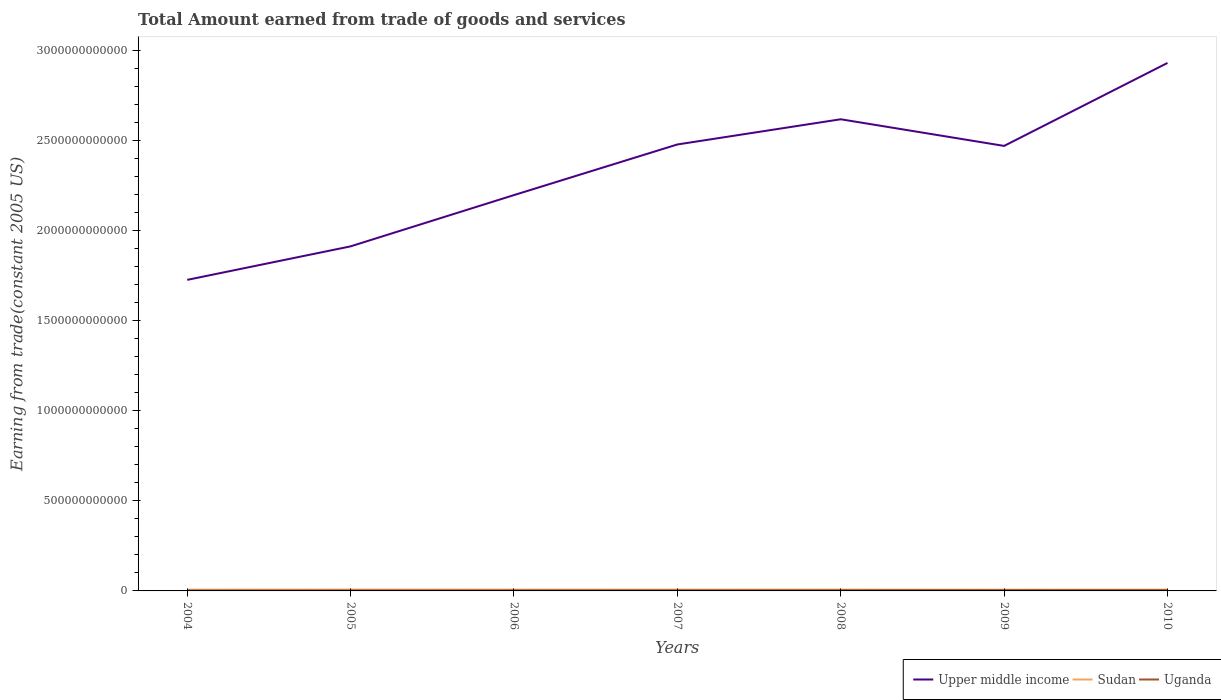How many different coloured lines are there?
Offer a very short reply. 3. Across all years, what is the maximum total amount earned by trading goods and services in Upper middle income?
Keep it short and to the point. 1.73e+12. In which year was the total amount earned by trading goods and services in Sudan maximum?
Your response must be concise. 2009. What is the total total amount earned by trading goods and services in Uganda in the graph?
Keep it short and to the point. 8.83e+07. What is the difference between the highest and the second highest total amount earned by trading goods and services in Uganda?
Provide a short and direct response. 2.28e+09. What is the difference between two consecutive major ticks on the Y-axis?
Your answer should be very brief. 5.00e+11. Are the values on the major ticks of Y-axis written in scientific E-notation?
Your answer should be compact. No. Does the graph contain any zero values?
Keep it short and to the point. No. Where does the legend appear in the graph?
Provide a short and direct response. Bottom right. How many legend labels are there?
Ensure brevity in your answer.  3. How are the legend labels stacked?
Your answer should be very brief. Horizontal. What is the title of the graph?
Your answer should be very brief. Total Amount earned from trade of goods and services. What is the label or title of the X-axis?
Offer a very short reply. Years. What is the label or title of the Y-axis?
Your answer should be compact. Earning from trade(constant 2005 US). What is the Earning from trade(constant 2005 US) of Upper middle income in 2004?
Give a very brief answer. 1.73e+12. What is the Earning from trade(constant 2005 US) in Sudan in 2004?
Give a very brief answer. 6.97e+09. What is the Earning from trade(constant 2005 US) of Uganda in 2004?
Your answer should be compact. 1.99e+09. What is the Earning from trade(constant 2005 US) of Upper middle income in 2005?
Your answer should be very brief. 1.91e+12. What is the Earning from trade(constant 2005 US) in Sudan in 2005?
Offer a terse response. 7.53e+09. What is the Earning from trade(constant 2005 US) in Uganda in 2005?
Your response must be concise. 2.24e+09. What is the Earning from trade(constant 2005 US) of Upper middle income in 2006?
Provide a short and direct response. 2.20e+12. What is the Earning from trade(constant 2005 US) of Sudan in 2006?
Make the answer very short. 7.20e+09. What is the Earning from trade(constant 2005 US) of Uganda in 2006?
Your answer should be very brief. 2.67e+09. What is the Earning from trade(constant 2005 US) of Upper middle income in 2007?
Ensure brevity in your answer.  2.48e+12. What is the Earning from trade(constant 2005 US) in Sudan in 2007?
Provide a succinct answer. 7.22e+09. What is the Earning from trade(constant 2005 US) of Uganda in 2007?
Your answer should be compact. 3.11e+09. What is the Earning from trade(constant 2005 US) in Upper middle income in 2008?
Make the answer very short. 2.62e+12. What is the Earning from trade(constant 2005 US) of Sudan in 2008?
Offer a very short reply. 7.24e+09. What is the Earning from trade(constant 2005 US) in Uganda in 2008?
Your answer should be compact. 3.65e+09. What is the Earning from trade(constant 2005 US) in Upper middle income in 2009?
Your answer should be very brief. 2.47e+12. What is the Earning from trade(constant 2005 US) of Sudan in 2009?
Your answer should be very brief. 6.72e+09. What is the Earning from trade(constant 2005 US) in Uganda in 2009?
Make the answer very short. 4.27e+09. What is the Earning from trade(constant 2005 US) in Upper middle income in 2010?
Your answer should be compact. 2.93e+12. What is the Earning from trade(constant 2005 US) of Sudan in 2010?
Keep it short and to the point. 7.17e+09. What is the Earning from trade(constant 2005 US) in Uganda in 2010?
Offer a terse response. 4.18e+09. Across all years, what is the maximum Earning from trade(constant 2005 US) of Upper middle income?
Ensure brevity in your answer.  2.93e+12. Across all years, what is the maximum Earning from trade(constant 2005 US) of Sudan?
Provide a succinct answer. 7.53e+09. Across all years, what is the maximum Earning from trade(constant 2005 US) of Uganda?
Your answer should be very brief. 4.27e+09. Across all years, what is the minimum Earning from trade(constant 2005 US) of Upper middle income?
Ensure brevity in your answer.  1.73e+12. Across all years, what is the minimum Earning from trade(constant 2005 US) of Sudan?
Offer a very short reply. 6.72e+09. Across all years, what is the minimum Earning from trade(constant 2005 US) of Uganda?
Offer a terse response. 1.99e+09. What is the total Earning from trade(constant 2005 US) of Upper middle income in the graph?
Your response must be concise. 1.63e+13. What is the total Earning from trade(constant 2005 US) of Sudan in the graph?
Keep it short and to the point. 5.01e+1. What is the total Earning from trade(constant 2005 US) of Uganda in the graph?
Keep it short and to the point. 2.21e+1. What is the difference between the Earning from trade(constant 2005 US) in Upper middle income in 2004 and that in 2005?
Give a very brief answer. -1.86e+11. What is the difference between the Earning from trade(constant 2005 US) in Sudan in 2004 and that in 2005?
Ensure brevity in your answer.  -5.68e+08. What is the difference between the Earning from trade(constant 2005 US) in Uganda in 2004 and that in 2005?
Keep it short and to the point. -2.50e+08. What is the difference between the Earning from trade(constant 2005 US) of Upper middle income in 2004 and that in 2006?
Offer a terse response. -4.70e+11. What is the difference between the Earning from trade(constant 2005 US) of Sudan in 2004 and that in 2006?
Your response must be concise. -2.36e+08. What is the difference between the Earning from trade(constant 2005 US) of Uganda in 2004 and that in 2006?
Keep it short and to the point. -6.86e+08. What is the difference between the Earning from trade(constant 2005 US) in Upper middle income in 2004 and that in 2007?
Your answer should be very brief. -7.51e+11. What is the difference between the Earning from trade(constant 2005 US) in Sudan in 2004 and that in 2007?
Your answer should be very brief. -2.58e+08. What is the difference between the Earning from trade(constant 2005 US) of Uganda in 2004 and that in 2007?
Ensure brevity in your answer.  -1.12e+09. What is the difference between the Earning from trade(constant 2005 US) of Upper middle income in 2004 and that in 2008?
Ensure brevity in your answer.  -8.91e+11. What is the difference between the Earning from trade(constant 2005 US) of Sudan in 2004 and that in 2008?
Your answer should be compact. -2.79e+08. What is the difference between the Earning from trade(constant 2005 US) of Uganda in 2004 and that in 2008?
Offer a very short reply. -1.66e+09. What is the difference between the Earning from trade(constant 2005 US) in Upper middle income in 2004 and that in 2009?
Your answer should be very brief. -7.43e+11. What is the difference between the Earning from trade(constant 2005 US) of Sudan in 2004 and that in 2009?
Your response must be concise. 2.51e+08. What is the difference between the Earning from trade(constant 2005 US) in Uganda in 2004 and that in 2009?
Provide a short and direct response. -2.28e+09. What is the difference between the Earning from trade(constant 2005 US) in Upper middle income in 2004 and that in 2010?
Provide a short and direct response. -1.20e+12. What is the difference between the Earning from trade(constant 2005 US) in Sudan in 2004 and that in 2010?
Your answer should be compact. -2.04e+08. What is the difference between the Earning from trade(constant 2005 US) in Uganda in 2004 and that in 2010?
Ensure brevity in your answer.  -2.19e+09. What is the difference between the Earning from trade(constant 2005 US) of Upper middle income in 2005 and that in 2006?
Provide a short and direct response. -2.84e+11. What is the difference between the Earning from trade(constant 2005 US) of Sudan in 2005 and that in 2006?
Offer a terse response. 3.31e+08. What is the difference between the Earning from trade(constant 2005 US) in Uganda in 2005 and that in 2006?
Keep it short and to the point. -4.37e+08. What is the difference between the Earning from trade(constant 2005 US) in Upper middle income in 2005 and that in 2007?
Your answer should be very brief. -5.65e+11. What is the difference between the Earning from trade(constant 2005 US) of Sudan in 2005 and that in 2007?
Your answer should be compact. 3.10e+08. What is the difference between the Earning from trade(constant 2005 US) in Uganda in 2005 and that in 2007?
Make the answer very short. -8.74e+08. What is the difference between the Earning from trade(constant 2005 US) of Upper middle income in 2005 and that in 2008?
Make the answer very short. -7.05e+11. What is the difference between the Earning from trade(constant 2005 US) of Sudan in 2005 and that in 2008?
Ensure brevity in your answer.  2.89e+08. What is the difference between the Earning from trade(constant 2005 US) of Uganda in 2005 and that in 2008?
Keep it short and to the point. -1.41e+09. What is the difference between the Earning from trade(constant 2005 US) in Upper middle income in 2005 and that in 2009?
Your answer should be very brief. -5.57e+11. What is the difference between the Earning from trade(constant 2005 US) in Sudan in 2005 and that in 2009?
Keep it short and to the point. 8.18e+08. What is the difference between the Earning from trade(constant 2005 US) in Uganda in 2005 and that in 2009?
Offer a terse response. -2.03e+09. What is the difference between the Earning from trade(constant 2005 US) in Upper middle income in 2005 and that in 2010?
Keep it short and to the point. -1.02e+12. What is the difference between the Earning from trade(constant 2005 US) in Sudan in 2005 and that in 2010?
Provide a short and direct response. 3.64e+08. What is the difference between the Earning from trade(constant 2005 US) in Uganda in 2005 and that in 2010?
Offer a very short reply. -1.94e+09. What is the difference between the Earning from trade(constant 2005 US) in Upper middle income in 2006 and that in 2007?
Your response must be concise. -2.81e+11. What is the difference between the Earning from trade(constant 2005 US) of Sudan in 2006 and that in 2007?
Ensure brevity in your answer.  -2.13e+07. What is the difference between the Earning from trade(constant 2005 US) in Uganda in 2006 and that in 2007?
Your answer should be compact. -4.37e+08. What is the difference between the Earning from trade(constant 2005 US) of Upper middle income in 2006 and that in 2008?
Provide a succinct answer. -4.21e+11. What is the difference between the Earning from trade(constant 2005 US) of Sudan in 2006 and that in 2008?
Your answer should be compact. -4.25e+07. What is the difference between the Earning from trade(constant 2005 US) in Uganda in 2006 and that in 2008?
Your answer should be compact. -9.78e+08. What is the difference between the Earning from trade(constant 2005 US) of Upper middle income in 2006 and that in 2009?
Make the answer very short. -2.73e+11. What is the difference between the Earning from trade(constant 2005 US) of Sudan in 2006 and that in 2009?
Ensure brevity in your answer.  4.87e+08. What is the difference between the Earning from trade(constant 2005 US) in Uganda in 2006 and that in 2009?
Offer a terse response. -1.59e+09. What is the difference between the Earning from trade(constant 2005 US) of Upper middle income in 2006 and that in 2010?
Your answer should be very brief. -7.33e+11. What is the difference between the Earning from trade(constant 2005 US) in Sudan in 2006 and that in 2010?
Your response must be concise. 3.29e+07. What is the difference between the Earning from trade(constant 2005 US) in Uganda in 2006 and that in 2010?
Ensure brevity in your answer.  -1.50e+09. What is the difference between the Earning from trade(constant 2005 US) in Upper middle income in 2007 and that in 2008?
Ensure brevity in your answer.  -1.40e+11. What is the difference between the Earning from trade(constant 2005 US) of Sudan in 2007 and that in 2008?
Your response must be concise. -2.12e+07. What is the difference between the Earning from trade(constant 2005 US) of Uganda in 2007 and that in 2008?
Your answer should be very brief. -5.40e+08. What is the difference between the Earning from trade(constant 2005 US) in Upper middle income in 2007 and that in 2009?
Give a very brief answer. 8.00e+09. What is the difference between the Earning from trade(constant 2005 US) of Sudan in 2007 and that in 2009?
Your response must be concise. 5.08e+08. What is the difference between the Earning from trade(constant 2005 US) in Uganda in 2007 and that in 2009?
Offer a very short reply. -1.16e+09. What is the difference between the Earning from trade(constant 2005 US) of Upper middle income in 2007 and that in 2010?
Keep it short and to the point. -4.52e+11. What is the difference between the Earning from trade(constant 2005 US) of Sudan in 2007 and that in 2010?
Your response must be concise. 5.42e+07. What is the difference between the Earning from trade(constant 2005 US) of Uganda in 2007 and that in 2010?
Keep it short and to the point. -1.07e+09. What is the difference between the Earning from trade(constant 2005 US) in Upper middle income in 2008 and that in 2009?
Offer a very short reply. 1.48e+11. What is the difference between the Earning from trade(constant 2005 US) in Sudan in 2008 and that in 2009?
Ensure brevity in your answer.  5.30e+08. What is the difference between the Earning from trade(constant 2005 US) of Uganda in 2008 and that in 2009?
Give a very brief answer. -6.15e+08. What is the difference between the Earning from trade(constant 2005 US) of Upper middle income in 2008 and that in 2010?
Give a very brief answer. -3.12e+11. What is the difference between the Earning from trade(constant 2005 US) of Sudan in 2008 and that in 2010?
Ensure brevity in your answer.  7.54e+07. What is the difference between the Earning from trade(constant 2005 US) of Uganda in 2008 and that in 2010?
Ensure brevity in your answer.  -5.27e+08. What is the difference between the Earning from trade(constant 2005 US) of Upper middle income in 2009 and that in 2010?
Ensure brevity in your answer.  -4.60e+11. What is the difference between the Earning from trade(constant 2005 US) in Sudan in 2009 and that in 2010?
Offer a very short reply. -4.54e+08. What is the difference between the Earning from trade(constant 2005 US) of Uganda in 2009 and that in 2010?
Ensure brevity in your answer.  8.83e+07. What is the difference between the Earning from trade(constant 2005 US) of Upper middle income in 2004 and the Earning from trade(constant 2005 US) of Sudan in 2005?
Your answer should be very brief. 1.72e+12. What is the difference between the Earning from trade(constant 2005 US) in Upper middle income in 2004 and the Earning from trade(constant 2005 US) in Uganda in 2005?
Provide a succinct answer. 1.72e+12. What is the difference between the Earning from trade(constant 2005 US) of Sudan in 2004 and the Earning from trade(constant 2005 US) of Uganda in 2005?
Your answer should be compact. 4.73e+09. What is the difference between the Earning from trade(constant 2005 US) in Upper middle income in 2004 and the Earning from trade(constant 2005 US) in Sudan in 2006?
Provide a short and direct response. 1.72e+12. What is the difference between the Earning from trade(constant 2005 US) in Upper middle income in 2004 and the Earning from trade(constant 2005 US) in Uganda in 2006?
Provide a short and direct response. 1.72e+12. What is the difference between the Earning from trade(constant 2005 US) in Sudan in 2004 and the Earning from trade(constant 2005 US) in Uganda in 2006?
Your response must be concise. 4.29e+09. What is the difference between the Earning from trade(constant 2005 US) of Upper middle income in 2004 and the Earning from trade(constant 2005 US) of Sudan in 2007?
Offer a very short reply. 1.72e+12. What is the difference between the Earning from trade(constant 2005 US) of Upper middle income in 2004 and the Earning from trade(constant 2005 US) of Uganda in 2007?
Your response must be concise. 1.72e+12. What is the difference between the Earning from trade(constant 2005 US) in Sudan in 2004 and the Earning from trade(constant 2005 US) in Uganda in 2007?
Provide a succinct answer. 3.86e+09. What is the difference between the Earning from trade(constant 2005 US) in Upper middle income in 2004 and the Earning from trade(constant 2005 US) in Sudan in 2008?
Offer a very short reply. 1.72e+12. What is the difference between the Earning from trade(constant 2005 US) in Upper middle income in 2004 and the Earning from trade(constant 2005 US) in Uganda in 2008?
Keep it short and to the point. 1.72e+12. What is the difference between the Earning from trade(constant 2005 US) in Sudan in 2004 and the Earning from trade(constant 2005 US) in Uganda in 2008?
Ensure brevity in your answer.  3.31e+09. What is the difference between the Earning from trade(constant 2005 US) of Upper middle income in 2004 and the Earning from trade(constant 2005 US) of Sudan in 2009?
Your answer should be very brief. 1.72e+12. What is the difference between the Earning from trade(constant 2005 US) of Upper middle income in 2004 and the Earning from trade(constant 2005 US) of Uganda in 2009?
Your answer should be very brief. 1.72e+12. What is the difference between the Earning from trade(constant 2005 US) in Sudan in 2004 and the Earning from trade(constant 2005 US) in Uganda in 2009?
Keep it short and to the point. 2.70e+09. What is the difference between the Earning from trade(constant 2005 US) of Upper middle income in 2004 and the Earning from trade(constant 2005 US) of Sudan in 2010?
Give a very brief answer. 1.72e+12. What is the difference between the Earning from trade(constant 2005 US) of Upper middle income in 2004 and the Earning from trade(constant 2005 US) of Uganda in 2010?
Your answer should be compact. 1.72e+12. What is the difference between the Earning from trade(constant 2005 US) in Sudan in 2004 and the Earning from trade(constant 2005 US) in Uganda in 2010?
Your answer should be compact. 2.79e+09. What is the difference between the Earning from trade(constant 2005 US) of Upper middle income in 2005 and the Earning from trade(constant 2005 US) of Sudan in 2006?
Your answer should be compact. 1.90e+12. What is the difference between the Earning from trade(constant 2005 US) of Upper middle income in 2005 and the Earning from trade(constant 2005 US) of Uganda in 2006?
Your response must be concise. 1.91e+12. What is the difference between the Earning from trade(constant 2005 US) of Sudan in 2005 and the Earning from trade(constant 2005 US) of Uganda in 2006?
Offer a terse response. 4.86e+09. What is the difference between the Earning from trade(constant 2005 US) in Upper middle income in 2005 and the Earning from trade(constant 2005 US) in Sudan in 2007?
Keep it short and to the point. 1.90e+12. What is the difference between the Earning from trade(constant 2005 US) of Upper middle income in 2005 and the Earning from trade(constant 2005 US) of Uganda in 2007?
Offer a very short reply. 1.91e+12. What is the difference between the Earning from trade(constant 2005 US) in Sudan in 2005 and the Earning from trade(constant 2005 US) in Uganda in 2007?
Offer a terse response. 4.42e+09. What is the difference between the Earning from trade(constant 2005 US) in Upper middle income in 2005 and the Earning from trade(constant 2005 US) in Sudan in 2008?
Your answer should be compact. 1.90e+12. What is the difference between the Earning from trade(constant 2005 US) of Upper middle income in 2005 and the Earning from trade(constant 2005 US) of Uganda in 2008?
Provide a succinct answer. 1.91e+12. What is the difference between the Earning from trade(constant 2005 US) in Sudan in 2005 and the Earning from trade(constant 2005 US) in Uganda in 2008?
Offer a terse response. 3.88e+09. What is the difference between the Earning from trade(constant 2005 US) of Upper middle income in 2005 and the Earning from trade(constant 2005 US) of Sudan in 2009?
Ensure brevity in your answer.  1.90e+12. What is the difference between the Earning from trade(constant 2005 US) of Upper middle income in 2005 and the Earning from trade(constant 2005 US) of Uganda in 2009?
Make the answer very short. 1.91e+12. What is the difference between the Earning from trade(constant 2005 US) of Sudan in 2005 and the Earning from trade(constant 2005 US) of Uganda in 2009?
Keep it short and to the point. 3.27e+09. What is the difference between the Earning from trade(constant 2005 US) of Upper middle income in 2005 and the Earning from trade(constant 2005 US) of Sudan in 2010?
Offer a very short reply. 1.90e+12. What is the difference between the Earning from trade(constant 2005 US) in Upper middle income in 2005 and the Earning from trade(constant 2005 US) in Uganda in 2010?
Make the answer very short. 1.91e+12. What is the difference between the Earning from trade(constant 2005 US) of Sudan in 2005 and the Earning from trade(constant 2005 US) of Uganda in 2010?
Provide a succinct answer. 3.36e+09. What is the difference between the Earning from trade(constant 2005 US) in Upper middle income in 2006 and the Earning from trade(constant 2005 US) in Sudan in 2007?
Your answer should be compact. 2.19e+12. What is the difference between the Earning from trade(constant 2005 US) in Upper middle income in 2006 and the Earning from trade(constant 2005 US) in Uganda in 2007?
Ensure brevity in your answer.  2.19e+12. What is the difference between the Earning from trade(constant 2005 US) of Sudan in 2006 and the Earning from trade(constant 2005 US) of Uganda in 2007?
Provide a succinct answer. 4.09e+09. What is the difference between the Earning from trade(constant 2005 US) of Upper middle income in 2006 and the Earning from trade(constant 2005 US) of Sudan in 2008?
Give a very brief answer. 2.19e+12. What is the difference between the Earning from trade(constant 2005 US) of Upper middle income in 2006 and the Earning from trade(constant 2005 US) of Uganda in 2008?
Make the answer very short. 2.19e+12. What is the difference between the Earning from trade(constant 2005 US) of Sudan in 2006 and the Earning from trade(constant 2005 US) of Uganda in 2008?
Keep it short and to the point. 3.55e+09. What is the difference between the Earning from trade(constant 2005 US) in Upper middle income in 2006 and the Earning from trade(constant 2005 US) in Sudan in 2009?
Provide a short and direct response. 2.19e+12. What is the difference between the Earning from trade(constant 2005 US) of Upper middle income in 2006 and the Earning from trade(constant 2005 US) of Uganda in 2009?
Give a very brief answer. 2.19e+12. What is the difference between the Earning from trade(constant 2005 US) of Sudan in 2006 and the Earning from trade(constant 2005 US) of Uganda in 2009?
Ensure brevity in your answer.  2.94e+09. What is the difference between the Earning from trade(constant 2005 US) in Upper middle income in 2006 and the Earning from trade(constant 2005 US) in Sudan in 2010?
Your answer should be very brief. 2.19e+12. What is the difference between the Earning from trade(constant 2005 US) of Upper middle income in 2006 and the Earning from trade(constant 2005 US) of Uganda in 2010?
Provide a short and direct response. 2.19e+12. What is the difference between the Earning from trade(constant 2005 US) of Sudan in 2006 and the Earning from trade(constant 2005 US) of Uganda in 2010?
Offer a terse response. 3.02e+09. What is the difference between the Earning from trade(constant 2005 US) of Upper middle income in 2007 and the Earning from trade(constant 2005 US) of Sudan in 2008?
Ensure brevity in your answer.  2.47e+12. What is the difference between the Earning from trade(constant 2005 US) in Upper middle income in 2007 and the Earning from trade(constant 2005 US) in Uganda in 2008?
Give a very brief answer. 2.47e+12. What is the difference between the Earning from trade(constant 2005 US) of Sudan in 2007 and the Earning from trade(constant 2005 US) of Uganda in 2008?
Give a very brief answer. 3.57e+09. What is the difference between the Earning from trade(constant 2005 US) of Upper middle income in 2007 and the Earning from trade(constant 2005 US) of Sudan in 2009?
Ensure brevity in your answer.  2.47e+12. What is the difference between the Earning from trade(constant 2005 US) in Upper middle income in 2007 and the Earning from trade(constant 2005 US) in Uganda in 2009?
Provide a succinct answer. 2.47e+12. What is the difference between the Earning from trade(constant 2005 US) in Sudan in 2007 and the Earning from trade(constant 2005 US) in Uganda in 2009?
Offer a very short reply. 2.96e+09. What is the difference between the Earning from trade(constant 2005 US) of Upper middle income in 2007 and the Earning from trade(constant 2005 US) of Sudan in 2010?
Keep it short and to the point. 2.47e+12. What is the difference between the Earning from trade(constant 2005 US) of Upper middle income in 2007 and the Earning from trade(constant 2005 US) of Uganda in 2010?
Your response must be concise. 2.47e+12. What is the difference between the Earning from trade(constant 2005 US) in Sudan in 2007 and the Earning from trade(constant 2005 US) in Uganda in 2010?
Keep it short and to the point. 3.05e+09. What is the difference between the Earning from trade(constant 2005 US) of Upper middle income in 2008 and the Earning from trade(constant 2005 US) of Sudan in 2009?
Ensure brevity in your answer.  2.61e+12. What is the difference between the Earning from trade(constant 2005 US) in Upper middle income in 2008 and the Earning from trade(constant 2005 US) in Uganda in 2009?
Make the answer very short. 2.61e+12. What is the difference between the Earning from trade(constant 2005 US) of Sudan in 2008 and the Earning from trade(constant 2005 US) of Uganda in 2009?
Your response must be concise. 2.98e+09. What is the difference between the Earning from trade(constant 2005 US) of Upper middle income in 2008 and the Earning from trade(constant 2005 US) of Sudan in 2010?
Your response must be concise. 2.61e+12. What is the difference between the Earning from trade(constant 2005 US) in Upper middle income in 2008 and the Earning from trade(constant 2005 US) in Uganda in 2010?
Your response must be concise. 2.61e+12. What is the difference between the Earning from trade(constant 2005 US) in Sudan in 2008 and the Earning from trade(constant 2005 US) in Uganda in 2010?
Ensure brevity in your answer.  3.07e+09. What is the difference between the Earning from trade(constant 2005 US) of Upper middle income in 2009 and the Earning from trade(constant 2005 US) of Sudan in 2010?
Give a very brief answer. 2.46e+12. What is the difference between the Earning from trade(constant 2005 US) in Upper middle income in 2009 and the Earning from trade(constant 2005 US) in Uganda in 2010?
Provide a succinct answer. 2.46e+12. What is the difference between the Earning from trade(constant 2005 US) of Sudan in 2009 and the Earning from trade(constant 2005 US) of Uganda in 2010?
Keep it short and to the point. 2.54e+09. What is the average Earning from trade(constant 2005 US) in Upper middle income per year?
Your answer should be very brief. 2.33e+12. What is the average Earning from trade(constant 2005 US) of Sudan per year?
Make the answer very short. 7.15e+09. What is the average Earning from trade(constant 2005 US) in Uganda per year?
Offer a terse response. 3.16e+09. In the year 2004, what is the difference between the Earning from trade(constant 2005 US) in Upper middle income and Earning from trade(constant 2005 US) in Sudan?
Ensure brevity in your answer.  1.72e+12. In the year 2004, what is the difference between the Earning from trade(constant 2005 US) in Upper middle income and Earning from trade(constant 2005 US) in Uganda?
Offer a very short reply. 1.72e+12. In the year 2004, what is the difference between the Earning from trade(constant 2005 US) of Sudan and Earning from trade(constant 2005 US) of Uganda?
Keep it short and to the point. 4.98e+09. In the year 2005, what is the difference between the Earning from trade(constant 2005 US) in Upper middle income and Earning from trade(constant 2005 US) in Sudan?
Your response must be concise. 1.90e+12. In the year 2005, what is the difference between the Earning from trade(constant 2005 US) in Upper middle income and Earning from trade(constant 2005 US) in Uganda?
Offer a very short reply. 1.91e+12. In the year 2005, what is the difference between the Earning from trade(constant 2005 US) in Sudan and Earning from trade(constant 2005 US) in Uganda?
Ensure brevity in your answer.  5.30e+09. In the year 2006, what is the difference between the Earning from trade(constant 2005 US) of Upper middle income and Earning from trade(constant 2005 US) of Sudan?
Provide a short and direct response. 2.19e+12. In the year 2006, what is the difference between the Earning from trade(constant 2005 US) in Upper middle income and Earning from trade(constant 2005 US) in Uganda?
Your answer should be compact. 2.19e+12. In the year 2006, what is the difference between the Earning from trade(constant 2005 US) of Sudan and Earning from trade(constant 2005 US) of Uganda?
Provide a short and direct response. 4.53e+09. In the year 2007, what is the difference between the Earning from trade(constant 2005 US) in Upper middle income and Earning from trade(constant 2005 US) in Sudan?
Offer a very short reply. 2.47e+12. In the year 2007, what is the difference between the Earning from trade(constant 2005 US) of Upper middle income and Earning from trade(constant 2005 US) of Uganda?
Your answer should be very brief. 2.47e+12. In the year 2007, what is the difference between the Earning from trade(constant 2005 US) in Sudan and Earning from trade(constant 2005 US) in Uganda?
Ensure brevity in your answer.  4.11e+09. In the year 2008, what is the difference between the Earning from trade(constant 2005 US) in Upper middle income and Earning from trade(constant 2005 US) in Sudan?
Your response must be concise. 2.61e+12. In the year 2008, what is the difference between the Earning from trade(constant 2005 US) of Upper middle income and Earning from trade(constant 2005 US) of Uganda?
Make the answer very short. 2.61e+12. In the year 2008, what is the difference between the Earning from trade(constant 2005 US) of Sudan and Earning from trade(constant 2005 US) of Uganda?
Offer a very short reply. 3.59e+09. In the year 2009, what is the difference between the Earning from trade(constant 2005 US) in Upper middle income and Earning from trade(constant 2005 US) in Sudan?
Provide a succinct answer. 2.46e+12. In the year 2009, what is the difference between the Earning from trade(constant 2005 US) of Upper middle income and Earning from trade(constant 2005 US) of Uganda?
Offer a very short reply. 2.46e+12. In the year 2009, what is the difference between the Earning from trade(constant 2005 US) in Sudan and Earning from trade(constant 2005 US) in Uganda?
Give a very brief answer. 2.45e+09. In the year 2010, what is the difference between the Earning from trade(constant 2005 US) in Upper middle income and Earning from trade(constant 2005 US) in Sudan?
Give a very brief answer. 2.92e+12. In the year 2010, what is the difference between the Earning from trade(constant 2005 US) of Upper middle income and Earning from trade(constant 2005 US) of Uganda?
Your answer should be very brief. 2.92e+12. In the year 2010, what is the difference between the Earning from trade(constant 2005 US) in Sudan and Earning from trade(constant 2005 US) in Uganda?
Provide a succinct answer. 2.99e+09. What is the ratio of the Earning from trade(constant 2005 US) of Upper middle income in 2004 to that in 2005?
Offer a very short reply. 0.9. What is the ratio of the Earning from trade(constant 2005 US) in Sudan in 2004 to that in 2005?
Your answer should be compact. 0.92. What is the ratio of the Earning from trade(constant 2005 US) in Uganda in 2004 to that in 2005?
Your answer should be very brief. 0.89. What is the ratio of the Earning from trade(constant 2005 US) in Upper middle income in 2004 to that in 2006?
Offer a very short reply. 0.79. What is the ratio of the Earning from trade(constant 2005 US) of Sudan in 2004 to that in 2006?
Give a very brief answer. 0.97. What is the ratio of the Earning from trade(constant 2005 US) of Uganda in 2004 to that in 2006?
Keep it short and to the point. 0.74. What is the ratio of the Earning from trade(constant 2005 US) in Upper middle income in 2004 to that in 2007?
Keep it short and to the point. 0.7. What is the ratio of the Earning from trade(constant 2005 US) of Uganda in 2004 to that in 2007?
Offer a very short reply. 0.64. What is the ratio of the Earning from trade(constant 2005 US) of Upper middle income in 2004 to that in 2008?
Your answer should be very brief. 0.66. What is the ratio of the Earning from trade(constant 2005 US) in Sudan in 2004 to that in 2008?
Give a very brief answer. 0.96. What is the ratio of the Earning from trade(constant 2005 US) in Uganda in 2004 to that in 2008?
Give a very brief answer. 0.54. What is the ratio of the Earning from trade(constant 2005 US) in Upper middle income in 2004 to that in 2009?
Provide a short and direct response. 0.7. What is the ratio of the Earning from trade(constant 2005 US) in Sudan in 2004 to that in 2009?
Offer a very short reply. 1.04. What is the ratio of the Earning from trade(constant 2005 US) of Uganda in 2004 to that in 2009?
Make the answer very short. 0.47. What is the ratio of the Earning from trade(constant 2005 US) of Upper middle income in 2004 to that in 2010?
Provide a succinct answer. 0.59. What is the ratio of the Earning from trade(constant 2005 US) of Sudan in 2004 to that in 2010?
Provide a succinct answer. 0.97. What is the ratio of the Earning from trade(constant 2005 US) in Uganda in 2004 to that in 2010?
Keep it short and to the point. 0.48. What is the ratio of the Earning from trade(constant 2005 US) of Upper middle income in 2005 to that in 2006?
Give a very brief answer. 0.87. What is the ratio of the Earning from trade(constant 2005 US) of Sudan in 2005 to that in 2006?
Offer a terse response. 1.05. What is the ratio of the Earning from trade(constant 2005 US) in Uganda in 2005 to that in 2006?
Offer a terse response. 0.84. What is the ratio of the Earning from trade(constant 2005 US) in Upper middle income in 2005 to that in 2007?
Your answer should be very brief. 0.77. What is the ratio of the Earning from trade(constant 2005 US) in Sudan in 2005 to that in 2007?
Ensure brevity in your answer.  1.04. What is the ratio of the Earning from trade(constant 2005 US) of Uganda in 2005 to that in 2007?
Keep it short and to the point. 0.72. What is the ratio of the Earning from trade(constant 2005 US) of Upper middle income in 2005 to that in 2008?
Offer a terse response. 0.73. What is the ratio of the Earning from trade(constant 2005 US) of Sudan in 2005 to that in 2008?
Provide a short and direct response. 1.04. What is the ratio of the Earning from trade(constant 2005 US) in Uganda in 2005 to that in 2008?
Provide a short and direct response. 0.61. What is the ratio of the Earning from trade(constant 2005 US) in Upper middle income in 2005 to that in 2009?
Offer a very short reply. 0.77. What is the ratio of the Earning from trade(constant 2005 US) of Sudan in 2005 to that in 2009?
Offer a terse response. 1.12. What is the ratio of the Earning from trade(constant 2005 US) in Uganda in 2005 to that in 2009?
Provide a succinct answer. 0.52. What is the ratio of the Earning from trade(constant 2005 US) in Upper middle income in 2005 to that in 2010?
Make the answer very short. 0.65. What is the ratio of the Earning from trade(constant 2005 US) of Sudan in 2005 to that in 2010?
Your answer should be compact. 1.05. What is the ratio of the Earning from trade(constant 2005 US) in Uganda in 2005 to that in 2010?
Provide a succinct answer. 0.54. What is the ratio of the Earning from trade(constant 2005 US) of Upper middle income in 2006 to that in 2007?
Offer a very short reply. 0.89. What is the ratio of the Earning from trade(constant 2005 US) in Sudan in 2006 to that in 2007?
Your answer should be compact. 1. What is the ratio of the Earning from trade(constant 2005 US) of Uganda in 2006 to that in 2007?
Provide a short and direct response. 0.86. What is the ratio of the Earning from trade(constant 2005 US) of Upper middle income in 2006 to that in 2008?
Give a very brief answer. 0.84. What is the ratio of the Earning from trade(constant 2005 US) of Uganda in 2006 to that in 2008?
Provide a short and direct response. 0.73. What is the ratio of the Earning from trade(constant 2005 US) in Upper middle income in 2006 to that in 2009?
Keep it short and to the point. 0.89. What is the ratio of the Earning from trade(constant 2005 US) in Sudan in 2006 to that in 2009?
Your response must be concise. 1.07. What is the ratio of the Earning from trade(constant 2005 US) in Uganda in 2006 to that in 2009?
Provide a short and direct response. 0.63. What is the ratio of the Earning from trade(constant 2005 US) of Upper middle income in 2006 to that in 2010?
Provide a succinct answer. 0.75. What is the ratio of the Earning from trade(constant 2005 US) of Uganda in 2006 to that in 2010?
Make the answer very short. 0.64. What is the ratio of the Earning from trade(constant 2005 US) of Upper middle income in 2007 to that in 2008?
Offer a very short reply. 0.95. What is the ratio of the Earning from trade(constant 2005 US) of Sudan in 2007 to that in 2008?
Your response must be concise. 1. What is the ratio of the Earning from trade(constant 2005 US) of Uganda in 2007 to that in 2008?
Your answer should be very brief. 0.85. What is the ratio of the Earning from trade(constant 2005 US) in Sudan in 2007 to that in 2009?
Give a very brief answer. 1.08. What is the ratio of the Earning from trade(constant 2005 US) in Uganda in 2007 to that in 2009?
Offer a terse response. 0.73. What is the ratio of the Earning from trade(constant 2005 US) in Upper middle income in 2007 to that in 2010?
Ensure brevity in your answer.  0.85. What is the ratio of the Earning from trade(constant 2005 US) in Sudan in 2007 to that in 2010?
Your response must be concise. 1.01. What is the ratio of the Earning from trade(constant 2005 US) in Uganda in 2007 to that in 2010?
Provide a succinct answer. 0.74. What is the ratio of the Earning from trade(constant 2005 US) in Upper middle income in 2008 to that in 2009?
Provide a succinct answer. 1.06. What is the ratio of the Earning from trade(constant 2005 US) of Sudan in 2008 to that in 2009?
Keep it short and to the point. 1.08. What is the ratio of the Earning from trade(constant 2005 US) in Uganda in 2008 to that in 2009?
Offer a very short reply. 0.86. What is the ratio of the Earning from trade(constant 2005 US) of Upper middle income in 2008 to that in 2010?
Provide a short and direct response. 0.89. What is the ratio of the Earning from trade(constant 2005 US) of Sudan in 2008 to that in 2010?
Make the answer very short. 1.01. What is the ratio of the Earning from trade(constant 2005 US) of Uganda in 2008 to that in 2010?
Provide a short and direct response. 0.87. What is the ratio of the Earning from trade(constant 2005 US) of Upper middle income in 2009 to that in 2010?
Your answer should be very brief. 0.84. What is the ratio of the Earning from trade(constant 2005 US) in Sudan in 2009 to that in 2010?
Offer a terse response. 0.94. What is the ratio of the Earning from trade(constant 2005 US) in Uganda in 2009 to that in 2010?
Your answer should be very brief. 1.02. What is the difference between the highest and the second highest Earning from trade(constant 2005 US) of Upper middle income?
Your response must be concise. 3.12e+11. What is the difference between the highest and the second highest Earning from trade(constant 2005 US) of Sudan?
Ensure brevity in your answer.  2.89e+08. What is the difference between the highest and the second highest Earning from trade(constant 2005 US) of Uganda?
Keep it short and to the point. 8.83e+07. What is the difference between the highest and the lowest Earning from trade(constant 2005 US) in Upper middle income?
Your answer should be very brief. 1.20e+12. What is the difference between the highest and the lowest Earning from trade(constant 2005 US) in Sudan?
Ensure brevity in your answer.  8.18e+08. What is the difference between the highest and the lowest Earning from trade(constant 2005 US) of Uganda?
Make the answer very short. 2.28e+09. 